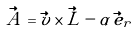<formula> <loc_0><loc_0><loc_500><loc_500>\vec { A } = \vec { v } \times \vec { L } - \alpha \, \vec { e } _ { r }</formula> 